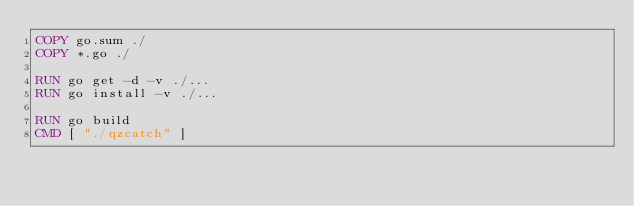Convert code to text. <code><loc_0><loc_0><loc_500><loc_500><_Dockerfile_>COPY go.sum ./
COPY *.go ./

RUN go get -d -v ./...
RUN go install -v ./...

RUN go build
CMD [ "./qzcatch" ]
</code> 